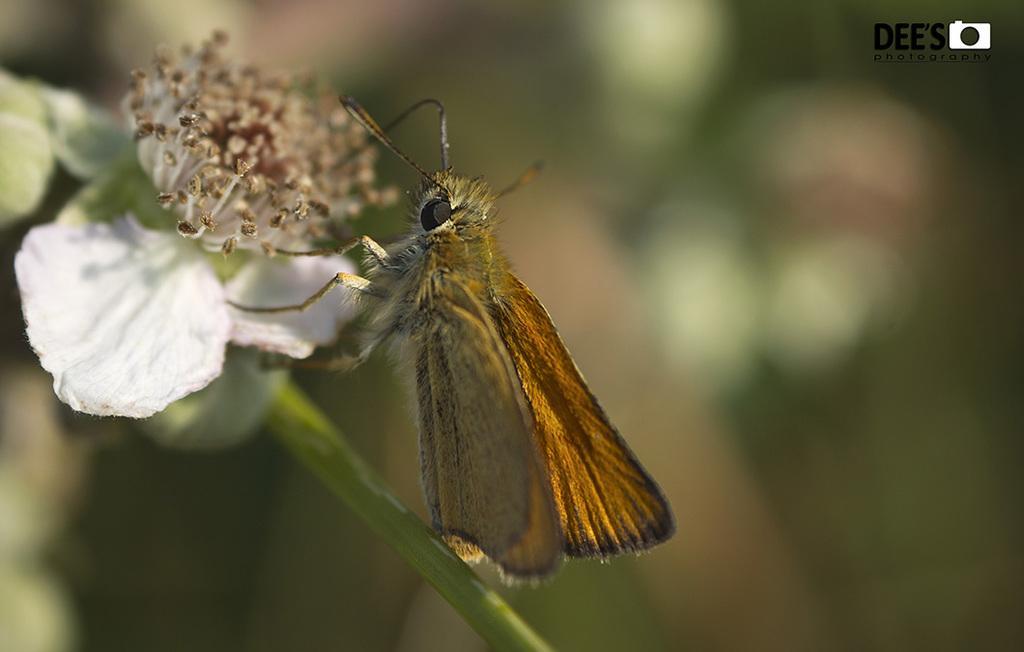Please provide a concise description of this image. In this image, we can see a butterfly sitting on the stem, there is a flower and there is a blur background. 